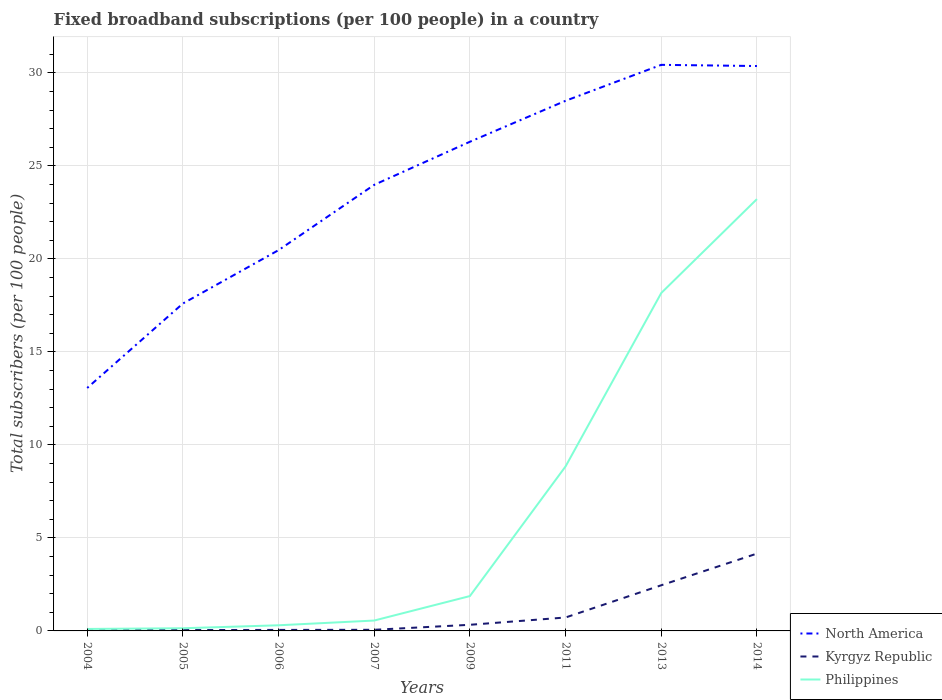How many different coloured lines are there?
Offer a terse response. 3. Is the number of lines equal to the number of legend labels?
Make the answer very short. Yes. Across all years, what is the maximum number of broadband subscriptions in Kyrgyz Republic?
Offer a terse response. 0.04. In which year was the number of broadband subscriptions in Kyrgyz Republic maximum?
Provide a succinct answer. 2004. What is the total number of broadband subscriptions in Kyrgyz Republic in the graph?
Your response must be concise. -4.1. What is the difference between the highest and the second highest number of broadband subscriptions in North America?
Your answer should be compact. 17.37. What is the difference between the highest and the lowest number of broadband subscriptions in Philippines?
Your answer should be very brief. 3. Is the number of broadband subscriptions in Philippines strictly greater than the number of broadband subscriptions in North America over the years?
Your response must be concise. Yes. How many lines are there?
Keep it short and to the point. 3. What is the difference between two consecutive major ticks on the Y-axis?
Ensure brevity in your answer.  5. Are the values on the major ticks of Y-axis written in scientific E-notation?
Your answer should be compact. No. Where does the legend appear in the graph?
Your response must be concise. Bottom right. What is the title of the graph?
Offer a very short reply. Fixed broadband subscriptions (per 100 people) in a country. Does "United Arab Emirates" appear as one of the legend labels in the graph?
Your answer should be compact. No. What is the label or title of the X-axis?
Your answer should be very brief. Years. What is the label or title of the Y-axis?
Your answer should be compact. Total subscribers (per 100 people). What is the Total subscribers (per 100 people) of North America in 2004?
Give a very brief answer. 13.06. What is the Total subscribers (per 100 people) in Kyrgyz Republic in 2004?
Provide a short and direct response. 0.04. What is the Total subscribers (per 100 people) of Philippines in 2004?
Your answer should be compact. 0.11. What is the Total subscribers (per 100 people) of North America in 2005?
Make the answer very short. 17.6. What is the Total subscribers (per 100 people) of Kyrgyz Republic in 2005?
Your response must be concise. 0.05. What is the Total subscribers (per 100 people) of Philippines in 2005?
Your answer should be compact. 0.14. What is the Total subscribers (per 100 people) of North America in 2006?
Your answer should be very brief. 20.47. What is the Total subscribers (per 100 people) of Kyrgyz Republic in 2006?
Your answer should be very brief. 0.05. What is the Total subscribers (per 100 people) of Philippines in 2006?
Offer a very short reply. 0.3. What is the Total subscribers (per 100 people) of North America in 2007?
Ensure brevity in your answer.  23.99. What is the Total subscribers (per 100 people) in Kyrgyz Republic in 2007?
Give a very brief answer. 0.06. What is the Total subscribers (per 100 people) of Philippines in 2007?
Your answer should be very brief. 0.56. What is the Total subscribers (per 100 people) in North America in 2009?
Offer a terse response. 26.3. What is the Total subscribers (per 100 people) in Kyrgyz Republic in 2009?
Provide a succinct answer. 0.33. What is the Total subscribers (per 100 people) in Philippines in 2009?
Your response must be concise. 1.87. What is the Total subscribers (per 100 people) of North America in 2011?
Provide a succinct answer. 28.51. What is the Total subscribers (per 100 people) in Kyrgyz Republic in 2011?
Ensure brevity in your answer.  0.72. What is the Total subscribers (per 100 people) of Philippines in 2011?
Give a very brief answer. 8.85. What is the Total subscribers (per 100 people) of North America in 2013?
Provide a short and direct response. 30.44. What is the Total subscribers (per 100 people) in Kyrgyz Republic in 2013?
Offer a very short reply. 2.46. What is the Total subscribers (per 100 people) in Philippines in 2013?
Provide a short and direct response. 18.17. What is the Total subscribers (per 100 people) in North America in 2014?
Your answer should be very brief. 30.37. What is the Total subscribers (per 100 people) in Kyrgyz Republic in 2014?
Your answer should be very brief. 4.16. What is the Total subscribers (per 100 people) in Philippines in 2014?
Offer a very short reply. 23.22. Across all years, what is the maximum Total subscribers (per 100 people) of North America?
Offer a very short reply. 30.44. Across all years, what is the maximum Total subscribers (per 100 people) in Kyrgyz Republic?
Provide a short and direct response. 4.16. Across all years, what is the maximum Total subscribers (per 100 people) of Philippines?
Your answer should be very brief. 23.22. Across all years, what is the minimum Total subscribers (per 100 people) in North America?
Give a very brief answer. 13.06. Across all years, what is the minimum Total subscribers (per 100 people) in Kyrgyz Republic?
Provide a succinct answer. 0.04. Across all years, what is the minimum Total subscribers (per 100 people) of Philippines?
Ensure brevity in your answer.  0.11. What is the total Total subscribers (per 100 people) in North America in the graph?
Provide a succinct answer. 190.75. What is the total Total subscribers (per 100 people) in Kyrgyz Republic in the graph?
Ensure brevity in your answer.  7.86. What is the total Total subscribers (per 100 people) in Philippines in the graph?
Your response must be concise. 53.22. What is the difference between the Total subscribers (per 100 people) of North America in 2004 and that in 2005?
Your answer should be compact. -4.54. What is the difference between the Total subscribers (per 100 people) of Kyrgyz Republic in 2004 and that in 2005?
Your answer should be very brief. -0.01. What is the difference between the Total subscribers (per 100 people) of Philippines in 2004 and that in 2005?
Ensure brevity in your answer.  -0.04. What is the difference between the Total subscribers (per 100 people) of North America in 2004 and that in 2006?
Provide a short and direct response. -7.41. What is the difference between the Total subscribers (per 100 people) of Kyrgyz Republic in 2004 and that in 2006?
Give a very brief answer. -0.02. What is the difference between the Total subscribers (per 100 people) of Philippines in 2004 and that in 2006?
Give a very brief answer. -0.2. What is the difference between the Total subscribers (per 100 people) of North America in 2004 and that in 2007?
Your response must be concise. -10.92. What is the difference between the Total subscribers (per 100 people) of Kyrgyz Republic in 2004 and that in 2007?
Provide a short and direct response. -0.02. What is the difference between the Total subscribers (per 100 people) in Philippines in 2004 and that in 2007?
Offer a very short reply. -0.45. What is the difference between the Total subscribers (per 100 people) in North America in 2004 and that in 2009?
Provide a succinct answer. -13.24. What is the difference between the Total subscribers (per 100 people) of Kyrgyz Republic in 2004 and that in 2009?
Provide a short and direct response. -0.29. What is the difference between the Total subscribers (per 100 people) of Philippines in 2004 and that in 2009?
Your answer should be very brief. -1.77. What is the difference between the Total subscribers (per 100 people) of North America in 2004 and that in 2011?
Your response must be concise. -15.44. What is the difference between the Total subscribers (per 100 people) of Kyrgyz Republic in 2004 and that in 2011?
Your response must be concise. -0.68. What is the difference between the Total subscribers (per 100 people) in Philippines in 2004 and that in 2011?
Your answer should be very brief. -8.74. What is the difference between the Total subscribers (per 100 people) of North America in 2004 and that in 2013?
Provide a short and direct response. -17.37. What is the difference between the Total subscribers (per 100 people) of Kyrgyz Republic in 2004 and that in 2013?
Your answer should be compact. -2.42. What is the difference between the Total subscribers (per 100 people) in Philippines in 2004 and that in 2013?
Ensure brevity in your answer.  -18.06. What is the difference between the Total subscribers (per 100 people) in North America in 2004 and that in 2014?
Provide a succinct answer. -17.31. What is the difference between the Total subscribers (per 100 people) in Kyrgyz Republic in 2004 and that in 2014?
Keep it short and to the point. -4.12. What is the difference between the Total subscribers (per 100 people) of Philippines in 2004 and that in 2014?
Your answer should be compact. -23.11. What is the difference between the Total subscribers (per 100 people) of North America in 2005 and that in 2006?
Offer a very short reply. -2.87. What is the difference between the Total subscribers (per 100 people) in Kyrgyz Republic in 2005 and that in 2006?
Offer a terse response. -0.01. What is the difference between the Total subscribers (per 100 people) in Philippines in 2005 and that in 2006?
Make the answer very short. -0.16. What is the difference between the Total subscribers (per 100 people) of North America in 2005 and that in 2007?
Make the answer very short. -6.38. What is the difference between the Total subscribers (per 100 people) of Kyrgyz Republic in 2005 and that in 2007?
Make the answer very short. -0.02. What is the difference between the Total subscribers (per 100 people) in Philippines in 2005 and that in 2007?
Your response must be concise. -0.41. What is the difference between the Total subscribers (per 100 people) of North America in 2005 and that in 2009?
Keep it short and to the point. -8.7. What is the difference between the Total subscribers (per 100 people) of Kyrgyz Republic in 2005 and that in 2009?
Make the answer very short. -0.28. What is the difference between the Total subscribers (per 100 people) of Philippines in 2005 and that in 2009?
Your answer should be compact. -1.73. What is the difference between the Total subscribers (per 100 people) of North America in 2005 and that in 2011?
Provide a short and direct response. -10.9. What is the difference between the Total subscribers (per 100 people) of Kyrgyz Republic in 2005 and that in 2011?
Your response must be concise. -0.68. What is the difference between the Total subscribers (per 100 people) in Philippines in 2005 and that in 2011?
Keep it short and to the point. -8.7. What is the difference between the Total subscribers (per 100 people) in North America in 2005 and that in 2013?
Offer a very short reply. -12.83. What is the difference between the Total subscribers (per 100 people) in Kyrgyz Republic in 2005 and that in 2013?
Offer a terse response. -2.41. What is the difference between the Total subscribers (per 100 people) in Philippines in 2005 and that in 2013?
Keep it short and to the point. -18.03. What is the difference between the Total subscribers (per 100 people) in North America in 2005 and that in 2014?
Ensure brevity in your answer.  -12.77. What is the difference between the Total subscribers (per 100 people) in Kyrgyz Republic in 2005 and that in 2014?
Your answer should be very brief. -4.11. What is the difference between the Total subscribers (per 100 people) in Philippines in 2005 and that in 2014?
Your response must be concise. -23.08. What is the difference between the Total subscribers (per 100 people) in North America in 2006 and that in 2007?
Provide a succinct answer. -3.51. What is the difference between the Total subscribers (per 100 people) of Kyrgyz Republic in 2006 and that in 2007?
Offer a very short reply. -0.01. What is the difference between the Total subscribers (per 100 people) of Philippines in 2006 and that in 2007?
Ensure brevity in your answer.  -0.25. What is the difference between the Total subscribers (per 100 people) in North America in 2006 and that in 2009?
Offer a terse response. -5.83. What is the difference between the Total subscribers (per 100 people) of Kyrgyz Republic in 2006 and that in 2009?
Your response must be concise. -0.28. What is the difference between the Total subscribers (per 100 people) in Philippines in 2006 and that in 2009?
Provide a short and direct response. -1.57. What is the difference between the Total subscribers (per 100 people) in North America in 2006 and that in 2011?
Provide a short and direct response. -8.03. What is the difference between the Total subscribers (per 100 people) in Kyrgyz Republic in 2006 and that in 2011?
Ensure brevity in your answer.  -0.67. What is the difference between the Total subscribers (per 100 people) of Philippines in 2006 and that in 2011?
Offer a very short reply. -8.54. What is the difference between the Total subscribers (per 100 people) of North America in 2006 and that in 2013?
Offer a terse response. -9.96. What is the difference between the Total subscribers (per 100 people) in Kyrgyz Republic in 2006 and that in 2013?
Offer a very short reply. -2.4. What is the difference between the Total subscribers (per 100 people) in Philippines in 2006 and that in 2013?
Your response must be concise. -17.87. What is the difference between the Total subscribers (per 100 people) of North America in 2006 and that in 2014?
Your answer should be compact. -9.9. What is the difference between the Total subscribers (per 100 people) in Kyrgyz Republic in 2006 and that in 2014?
Your answer should be very brief. -4.1. What is the difference between the Total subscribers (per 100 people) in Philippines in 2006 and that in 2014?
Make the answer very short. -22.92. What is the difference between the Total subscribers (per 100 people) of North America in 2007 and that in 2009?
Offer a very short reply. -2.32. What is the difference between the Total subscribers (per 100 people) in Kyrgyz Republic in 2007 and that in 2009?
Make the answer very short. -0.27. What is the difference between the Total subscribers (per 100 people) of Philippines in 2007 and that in 2009?
Make the answer very short. -1.32. What is the difference between the Total subscribers (per 100 people) in North America in 2007 and that in 2011?
Give a very brief answer. -4.52. What is the difference between the Total subscribers (per 100 people) of Kyrgyz Republic in 2007 and that in 2011?
Your answer should be compact. -0.66. What is the difference between the Total subscribers (per 100 people) of Philippines in 2007 and that in 2011?
Give a very brief answer. -8.29. What is the difference between the Total subscribers (per 100 people) in North America in 2007 and that in 2013?
Provide a short and direct response. -6.45. What is the difference between the Total subscribers (per 100 people) of Kyrgyz Republic in 2007 and that in 2013?
Your answer should be very brief. -2.39. What is the difference between the Total subscribers (per 100 people) in Philippines in 2007 and that in 2013?
Provide a short and direct response. -17.61. What is the difference between the Total subscribers (per 100 people) of North America in 2007 and that in 2014?
Give a very brief answer. -6.39. What is the difference between the Total subscribers (per 100 people) in Kyrgyz Republic in 2007 and that in 2014?
Make the answer very short. -4.1. What is the difference between the Total subscribers (per 100 people) in Philippines in 2007 and that in 2014?
Provide a short and direct response. -22.66. What is the difference between the Total subscribers (per 100 people) in North America in 2009 and that in 2011?
Offer a terse response. -2.2. What is the difference between the Total subscribers (per 100 people) of Kyrgyz Republic in 2009 and that in 2011?
Offer a very short reply. -0.39. What is the difference between the Total subscribers (per 100 people) of Philippines in 2009 and that in 2011?
Keep it short and to the point. -6.97. What is the difference between the Total subscribers (per 100 people) in North America in 2009 and that in 2013?
Provide a short and direct response. -4.14. What is the difference between the Total subscribers (per 100 people) in Kyrgyz Republic in 2009 and that in 2013?
Your answer should be compact. -2.13. What is the difference between the Total subscribers (per 100 people) of Philippines in 2009 and that in 2013?
Provide a short and direct response. -16.3. What is the difference between the Total subscribers (per 100 people) of North America in 2009 and that in 2014?
Your answer should be very brief. -4.07. What is the difference between the Total subscribers (per 100 people) in Kyrgyz Republic in 2009 and that in 2014?
Provide a succinct answer. -3.83. What is the difference between the Total subscribers (per 100 people) of Philippines in 2009 and that in 2014?
Offer a very short reply. -21.34. What is the difference between the Total subscribers (per 100 people) of North America in 2011 and that in 2013?
Give a very brief answer. -1.93. What is the difference between the Total subscribers (per 100 people) in Kyrgyz Republic in 2011 and that in 2013?
Make the answer very short. -1.73. What is the difference between the Total subscribers (per 100 people) of Philippines in 2011 and that in 2013?
Provide a succinct answer. -9.32. What is the difference between the Total subscribers (per 100 people) in North America in 2011 and that in 2014?
Ensure brevity in your answer.  -1.87. What is the difference between the Total subscribers (per 100 people) of Kyrgyz Republic in 2011 and that in 2014?
Your answer should be very brief. -3.44. What is the difference between the Total subscribers (per 100 people) in Philippines in 2011 and that in 2014?
Offer a terse response. -14.37. What is the difference between the Total subscribers (per 100 people) in North America in 2013 and that in 2014?
Provide a short and direct response. 0.06. What is the difference between the Total subscribers (per 100 people) of Kyrgyz Republic in 2013 and that in 2014?
Provide a succinct answer. -1.7. What is the difference between the Total subscribers (per 100 people) of Philippines in 2013 and that in 2014?
Keep it short and to the point. -5.05. What is the difference between the Total subscribers (per 100 people) in North America in 2004 and the Total subscribers (per 100 people) in Kyrgyz Republic in 2005?
Your answer should be compact. 13.02. What is the difference between the Total subscribers (per 100 people) of North America in 2004 and the Total subscribers (per 100 people) of Philippines in 2005?
Offer a very short reply. 12.92. What is the difference between the Total subscribers (per 100 people) in Kyrgyz Republic in 2004 and the Total subscribers (per 100 people) in Philippines in 2005?
Keep it short and to the point. -0.11. What is the difference between the Total subscribers (per 100 people) of North America in 2004 and the Total subscribers (per 100 people) of Kyrgyz Republic in 2006?
Offer a terse response. 13.01. What is the difference between the Total subscribers (per 100 people) in North America in 2004 and the Total subscribers (per 100 people) in Philippines in 2006?
Your answer should be very brief. 12.76. What is the difference between the Total subscribers (per 100 people) of Kyrgyz Republic in 2004 and the Total subscribers (per 100 people) of Philippines in 2006?
Your answer should be compact. -0.27. What is the difference between the Total subscribers (per 100 people) in North America in 2004 and the Total subscribers (per 100 people) in Kyrgyz Republic in 2007?
Provide a succinct answer. 13. What is the difference between the Total subscribers (per 100 people) of North America in 2004 and the Total subscribers (per 100 people) of Philippines in 2007?
Offer a terse response. 12.5. What is the difference between the Total subscribers (per 100 people) in Kyrgyz Republic in 2004 and the Total subscribers (per 100 people) in Philippines in 2007?
Ensure brevity in your answer.  -0.52. What is the difference between the Total subscribers (per 100 people) of North America in 2004 and the Total subscribers (per 100 people) of Kyrgyz Republic in 2009?
Offer a very short reply. 12.73. What is the difference between the Total subscribers (per 100 people) of North America in 2004 and the Total subscribers (per 100 people) of Philippines in 2009?
Provide a succinct answer. 11.19. What is the difference between the Total subscribers (per 100 people) in Kyrgyz Republic in 2004 and the Total subscribers (per 100 people) in Philippines in 2009?
Give a very brief answer. -1.84. What is the difference between the Total subscribers (per 100 people) in North America in 2004 and the Total subscribers (per 100 people) in Kyrgyz Republic in 2011?
Your answer should be very brief. 12.34. What is the difference between the Total subscribers (per 100 people) in North America in 2004 and the Total subscribers (per 100 people) in Philippines in 2011?
Make the answer very short. 4.22. What is the difference between the Total subscribers (per 100 people) of Kyrgyz Republic in 2004 and the Total subscribers (per 100 people) of Philippines in 2011?
Offer a terse response. -8.81. What is the difference between the Total subscribers (per 100 people) of North America in 2004 and the Total subscribers (per 100 people) of Kyrgyz Republic in 2013?
Ensure brevity in your answer.  10.61. What is the difference between the Total subscribers (per 100 people) in North America in 2004 and the Total subscribers (per 100 people) in Philippines in 2013?
Your answer should be very brief. -5.11. What is the difference between the Total subscribers (per 100 people) of Kyrgyz Republic in 2004 and the Total subscribers (per 100 people) of Philippines in 2013?
Offer a terse response. -18.13. What is the difference between the Total subscribers (per 100 people) of North America in 2004 and the Total subscribers (per 100 people) of Kyrgyz Republic in 2014?
Your answer should be very brief. 8.9. What is the difference between the Total subscribers (per 100 people) of North America in 2004 and the Total subscribers (per 100 people) of Philippines in 2014?
Provide a succinct answer. -10.16. What is the difference between the Total subscribers (per 100 people) of Kyrgyz Republic in 2004 and the Total subscribers (per 100 people) of Philippines in 2014?
Your answer should be compact. -23.18. What is the difference between the Total subscribers (per 100 people) of North America in 2005 and the Total subscribers (per 100 people) of Kyrgyz Republic in 2006?
Offer a very short reply. 17.55. What is the difference between the Total subscribers (per 100 people) in North America in 2005 and the Total subscribers (per 100 people) in Philippines in 2006?
Your answer should be very brief. 17.3. What is the difference between the Total subscribers (per 100 people) of Kyrgyz Republic in 2005 and the Total subscribers (per 100 people) of Philippines in 2006?
Offer a terse response. -0.26. What is the difference between the Total subscribers (per 100 people) in North America in 2005 and the Total subscribers (per 100 people) in Kyrgyz Republic in 2007?
Provide a succinct answer. 17.54. What is the difference between the Total subscribers (per 100 people) of North America in 2005 and the Total subscribers (per 100 people) of Philippines in 2007?
Ensure brevity in your answer.  17.05. What is the difference between the Total subscribers (per 100 people) in Kyrgyz Republic in 2005 and the Total subscribers (per 100 people) in Philippines in 2007?
Your response must be concise. -0.51. What is the difference between the Total subscribers (per 100 people) in North America in 2005 and the Total subscribers (per 100 people) in Kyrgyz Republic in 2009?
Keep it short and to the point. 17.27. What is the difference between the Total subscribers (per 100 people) in North America in 2005 and the Total subscribers (per 100 people) in Philippines in 2009?
Offer a terse response. 15.73. What is the difference between the Total subscribers (per 100 people) in Kyrgyz Republic in 2005 and the Total subscribers (per 100 people) in Philippines in 2009?
Keep it short and to the point. -1.83. What is the difference between the Total subscribers (per 100 people) in North America in 2005 and the Total subscribers (per 100 people) in Kyrgyz Republic in 2011?
Your answer should be very brief. 16.88. What is the difference between the Total subscribers (per 100 people) in North America in 2005 and the Total subscribers (per 100 people) in Philippines in 2011?
Keep it short and to the point. 8.76. What is the difference between the Total subscribers (per 100 people) of Kyrgyz Republic in 2005 and the Total subscribers (per 100 people) of Philippines in 2011?
Provide a short and direct response. -8.8. What is the difference between the Total subscribers (per 100 people) of North America in 2005 and the Total subscribers (per 100 people) of Kyrgyz Republic in 2013?
Provide a short and direct response. 15.15. What is the difference between the Total subscribers (per 100 people) in North America in 2005 and the Total subscribers (per 100 people) in Philippines in 2013?
Ensure brevity in your answer.  -0.57. What is the difference between the Total subscribers (per 100 people) of Kyrgyz Republic in 2005 and the Total subscribers (per 100 people) of Philippines in 2013?
Offer a very short reply. -18.12. What is the difference between the Total subscribers (per 100 people) in North America in 2005 and the Total subscribers (per 100 people) in Kyrgyz Republic in 2014?
Your response must be concise. 13.45. What is the difference between the Total subscribers (per 100 people) in North America in 2005 and the Total subscribers (per 100 people) in Philippines in 2014?
Make the answer very short. -5.62. What is the difference between the Total subscribers (per 100 people) in Kyrgyz Republic in 2005 and the Total subscribers (per 100 people) in Philippines in 2014?
Give a very brief answer. -23.17. What is the difference between the Total subscribers (per 100 people) in North America in 2006 and the Total subscribers (per 100 people) in Kyrgyz Republic in 2007?
Offer a very short reply. 20.41. What is the difference between the Total subscribers (per 100 people) of North America in 2006 and the Total subscribers (per 100 people) of Philippines in 2007?
Your response must be concise. 19.92. What is the difference between the Total subscribers (per 100 people) in Kyrgyz Republic in 2006 and the Total subscribers (per 100 people) in Philippines in 2007?
Ensure brevity in your answer.  -0.5. What is the difference between the Total subscribers (per 100 people) in North America in 2006 and the Total subscribers (per 100 people) in Kyrgyz Republic in 2009?
Your answer should be very brief. 20.14. What is the difference between the Total subscribers (per 100 people) of North America in 2006 and the Total subscribers (per 100 people) of Philippines in 2009?
Your answer should be very brief. 18.6. What is the difference between the Total subscribers (per 100 people) of Kyrgyz Republic in 2006 and the Total subscribers (per 100 people) of Philippines in 2009?
Give a very brief answer. -1.82. What is the difference between the Total subscribers (per 100 people) of North America in 2006 and the Total subscribers (per 100 people) of Kyrgyz Republic in 2011?
Your answer should be compact. 19.75. What is the difference between the Total subscribers (per 100 people) in North America in 2006 and the Total subscribers (per 100 people) in Philippines in 2011?
Your response must be concise. 11.63. What is the difference between the Total subscribers (per 100 people) of Kyrgyz Republic in 2006 and the Total subscribers (per 100 people) of Philippines in 2011?
Your answer should be compact. -8.79. What is the difference between the Total subscribers (per 100 people) in North America in 2006 and the Total subscribers (per 100 people) in Kyrgyz Republic in 2013?
Provide a short and direct response. 18.02. What is the difference between the Total subscribers (per 100 people) in North America in 2006 and the Total subscribers (per 100 people) in Philippines in 2013?
Make the answer very short. 2.3. What is the difference between the Total subscribers (per 100 people) in Kyrgyz Republic in 2006 and the Total subscribers (per 100 people) in Philippines in 2013?
Provide a succinct answer. -18.12. What is the difference between the Total subscribers (per 100 people) in North America in 2006 and the Total subscribers (per 100 people) in Kyrgyz Republic in 2014?
Give a very brief answer. 16.32. What is the difference between the Total subscribers (per 100 people) of North America in 2006 and the Total subscribers (per 100 people) of Philippines in 2014?
Provide a short and direct response. -2.75. What is the difference between the Total subscribers (per 100 people) in Kyrgyz Republic in 2006 and the Total subscribers (per 100 people) in Philippines in 2014?
Ensure brevity in your answer.  -23.16. What is the difference between the Total subscribers (per 100 people) in North America in 2007 and the Total subscribers (per 100 people) in Kyrgyz Republic in 2009?
Provide a short and direct response. 23.66. What is the difference between the Total subscribers (per 100 people) of North America in 2007 and the Total subscribers (per 100 people) of Philippines in 2009?
Make the answer very short. 22.11. What is the difference between the Total subscribers (per 100 people) in Kyrgyz Republic in 2007 and the Total subscribers (per 100 people) in Philippines in 2009?
Give a very brief answer. -1.81. What is the difference between the Total subscribers (per 100 people) in North America in 2007 and the Total subscribers (per 100 people) in Kyrgyz Republic in 2011?
Provide a short and direct response. 23.26. What is the difference between the Total subscribers (per 100 people) in North America in 2007 and the Total subscribers (per 100 people) in Philippines in 2011?
Make the answer very short. 15.14. What is the difference between the Total subscribers (per 100 people) in Kyrgyz Republic in 2007 and the Total subscribers (per 100 people) in Philippines in 2011?
Provide a succinct answer. -8.79. What is the difference between the Total subscribers (per 100 people) of North America in 2007 and the Total subscribers (per 100 people) of Kyrgyz Republic in 2013?
Your response must be concise. 21.53. What is the difference between the Total subscribers (per 100 people) in North America in 2007 and the Total subscribers (per 100 people) in Philippines in 2013?
Ensure brevity in your answer.  5.82. What is the difference between the Total subscribers (per 100 people) of Kyrgyz Republic in 2007 and the Total subscribers (per 100 people) of Philippines in 2013?
Offer a terse response. -18.11. What is the difference between the Total subscribers (per 100 people) of North America in 2007 and the Total subscribers (per 100 people) of Kyrgyz Republic in 2014?
Your response must be concise. 19.83. What is the difference between the Total subscribers (per 100 people) in North America in 2007 and the Total subscribers (per 100 people) in Philippines in 2014?
Ensure brevity in your answer.  0.77. What is the difference between the Total subscribers (per 100 people) of Kyrgyz Republic in 2007 and the Total subscribers (per 100 people) of Philippines in 2014?
Keep it short and to the point. -23.16. What is the difference between the Total subscribers (per 100 people) in North America in 2009 and the Total subscribers (per 100 people) in Kyrgyz Republic in 2011?
Your response must be concise. 25.58. What is the difference between the Total subscribers (per 100 people) of North America in 2009 and the Total subscribers (per 100 people) of Philippines in 2011?
Provide a succinct answer. 17.46. What is the difference between the Total subscribers (per 100 people) of Kyrgyz Republic in 2009 and the Total subscribers (per 100 people) of Philippines in 2011?
Your answer should be compact. -8.52. What is the difference between the Total subscribers (per 100 people) in North America in 2009 and the Total subscribers (per 100 people) in Kyrgyz Republic in 2013?
Provide a short and direct response. 23.85. What is the difference between the Total subscribers (per 100 people) in North America in 2009 and the Total subscribers (per 100 people) in Philippines in 2013?
Give a very brief answer. 8.13. What is the difference between the Total subscribers (per 100 people) of Kyrgyz Republic in 2009 and the Total subscribers (per 100 people) of Philippines in 2013?
Your response must be concise. -17.84. What is the difference between the Total subscribers (per 100 people) in North America in 2009 and the Total subscribers (per 100 people) in Kyrgyz Republic in 2014?
Offer a very short reply. 22.14. What is the difference between the Total subscribers (per 100 people) in North America in 2009 and the Total subscribers (per 100 people) in Philippines in 2014?
Give a very brief answer. 3.08. What is the difference between the Total subscribers (per 100 people) in Kyrgyz Republic in 2009 and the Total subscribers (per 100 people) in Philippines in 2014?
Provide a succinct answer. -22.89. What is the difference between the Total subscribers (per 100 people) in North America in 2011 and the Total subscribers (per 100 people) in Kyrgyz Republic in 2013?
Offer a very short reply. 26.05. What is the difference between the Total subscribers (per 100 people) in North America in 2011 and the Total subscribers (per 100 people) in Philippines in 2013?
Your answer should be very brief. 10.34. What is the difference between the Total subscribers (per 100 people) in Kyrgyz Republic in 2011 and the Total subscribers (per 100 people) in Philippines in 2013?
Give a very brief answer. -17.45. What is the difference between the Total subscribers (per 100 people) in North America in 2011 and the Total subscribers (per 100 people) in Kyrgyz Republic in 2014?
Your answer should be very brief. 24.35. What is the difference between the Total subscribers (per 100 people) of North America in 2011 and the Total subscribers (per 100 people) of Philippines in 2014?
Provide a short and direct response. 5.29. What is the difference between the Total subscribers (per 100 people) in Kyrgyz Republic in 2011 and the Total subscribers (per 100 people) in Philippines in 2014?
Your response must be concise. -22.5. What is the difference between the Total subscribers (per 100 people) of North America in 2013 and the Total subscribers (per 100 people) of Kyrgyz Republic in 2014?
Keep it short and to the point. 26.28. What is the difference between the Total subscribers (per 100 people) in North America in 2013 and the Total subscribers (per 100 people) in Philippines in 2014?
Offer a very short reply. 7.22. What is the difference between the Total subscribers (per 100 people) in Kyrgyz Republic in 2013 and the Total subscribers (per 100 people) in Philippines in 2014?
Your response must be concise. -20.76. What is the average Total subscribers (per 100 people) in North America per year?
Your answer should be compact. 23.84. What is the average Total subscribers (per 100 people) of Kyrgyz Republic per year?
Offer a terse response. 0.98. What is the average Total subscribers (per 100 people) of Philippines per year?
Offer a terse response. 6.65. In the year 2004, what is the difference between the Total subscribers (per 100 people) in North America and Total subscribers (per 100 people) in Kyrgyz Republic?
Offer a terse response. 13.03. In the year 2004, what is the difference between the Total subscribers (per 100 people) of North America and Total subscribers (per 100 people) of Philippines?
Keep it short and to the point. 12.96. In the year 2004, what is the difference between the Total subscribers (per 100 people) of Kyrgyz Republic and Total subscribers (per 100 people) of Philippines?
Ensure brevity in your answer.  -0.07. In the year 2005, what is the difference between the Total subscribers (per 100 people) of North America and Total subscribers (per 100 people) of Kyrgyz Republic?
Offer a very short reply. 17.56. In the year 2005, what is the difference between the Total subscribers (per 100 people) of North America and Total subscribers (per 100 people) of Philippines?
Provide a succinct answer. 17.46. In the year 2005, what is the difference between the Total subscribers (per 100 people) of Kyrgyz Republic and Total subscribers (per 100 people) of Philippines?
Provide a short and direct response. -0.1. In the year 2006, what is the difference between the Total subscribers (per 100 people) in North America and Total subscribers (per 100 people) in Kyrgyz Republic?
Your response must be concise. 20.42. In the year 2006, what is the difference between the Total subscribers (per 100 people) in North America and Total subscribers (per 100 people) in Philippines?
Offer a terse response. 20.17. In the year 2006, what is the difference between the Total subscribers (per 100 people) of Kyrgyz Republic and Total subscribers (per 100 people) of Philippines?
Keep it short and to the point. -0.25. In the year 2007, what is the difference between the Total subscribers (per 100 people) of North America and Total subscribers (per 100 people) of Kyrgyz Republic?
Make the answer very short. 23.93. In the year 2007, what is the difference between the Total subscribers (per 100 people) in North America and Total subscribers (per 100 people) in Philippines?
Your answer should be very brief. 23.43. In the year 2007, what is the difference between the Total subscribers (per 100 people) of Kyrgyz Republic and Total subscribers (per 100 people) of Philippines?
Keep it short and to the point. -0.5. In the year 2009, what is the difference between the Total subscribers (per 100 people) in North America and Total subscribers (per 100 people) in Kyrgyz Republic?
Offer a very short reply. 25.97. In the year 2009, what is the difference between the Total subscribers (per 100 people) in North America and Total subscribers (per 100 people) in Philippines?
Ensure brevity in your answer.  24.43. In the year 2009, what is the difference between the Total subscribers (per 100 people) in Kyrgyz Republic and Total subscribers (per 100 people) in Philippines?
Provide a short and direct response. -1.54. In the year 2011, what is the difference between the Total subscribers (per 100 people) of North America and Total subscribers (per 100 people) of Kyrgyz Republic?
Your answer should be very brief. 27.78. In the year 2011, what is the difference between the Total subscribers (per 100 people) in North America and Total subscribers (per 100 people) in Philippines?
Your answer should be compact. 19.66. In the year 2011, what is the difference between the Total subscribers (per 100 people) in Kyrgyz Republic and Total subscribers (per 100 people) in Philippines?
Make the answer very short. -8.12. In the year 2013, what is the difference between the Total subscribers (per 100 people) of North America and Total subscribers (per 100 people) of Kyrgyz Republic?
Ensure brevity in your answer.  27.98. In the year 2013, what is the difference between the Total subscribers (per 100 people) in North America and Total subscribers (per 100 people) in Philippines?
Provide a succinct answer. 12.27. In the year 2013, what is the difference between the Total subscribers (per 100 people) in Kyrgyz Republic and Total subscribers (per 100 people) in Philippines?
Your answer should be very brief. -15.71. In the year 2014, what is the difference between the Total subscribers (per 100 people) of North America and Total subscribers (per 100 people) of Kyrgyz Republic?
Make the answer very short. 26.22. In the year 2014, what is the difference between the Total subscribers (per 100 people) of North America and Total subscribers (per 100 people) of Philippines?
Provide a succinct answer. 7.15. In the year 2014, what is the difference between the Total subscribers (per 100 people) in Kyrgyz Republic and Total subscribers (per 100 people) in Philippines?
Ensure brevity in your answer.  -19.06. What is the ratio of the Total subscribers (per 100 people) of North America in 2004 to that in 2005?
Ensure brevity in your answer.  0.74. What is the ratio of the Total subscribers (per 100 people) in Kyrgyz Republic in 2004 to that in 2005?
Your answer should be compact. 0.84. What is the ratio of the Total subscribers (per 100 people) in Philippines in 2004 to that in 2005?
Make the answer very short. 0.74. What is the ratio of the Total subscribers (per 100 people) in North America in 2004 to that in 2006?
Your answer should be compact. 0.64. What is the ratio of the Total subscribers (per 100 people) in Kyrgyz Republic in 2004 to that in 2006?
Give a very brief answer. 0.7. What is the ratio of the Total subscribers (per 100 people) in Philippines in 2004 to that in 2006?
Ensure brevity in your answer.  0.35. What is the ratio of the Total subscribers (per 100 people) of North America in 2004 to that in 2007?
Your answer should be very brief. 0.54. What is the ratio of the Total subscribers (per 100 people) of Kyrgyz Republic in 2004 to that in 2007?
Offer a very short reply. 0.63. What is the ratio of the Total subscribers (per 100 people) in Philippines in 2004 to that in 2007?
Make the answer very short. 0.19. What is the ratio of the Total subscribers (per 100 people) of North America in 2004 to that in 2009?
Your answer should be compact. 0.5. What is the ratio of the Total subscribers (per 100 people) in Kyrgyz Republic in 2004 to that in 2009?
Offer a terse response. 0.12. What is the ratio of the Total subscribers (per 100 people) of Philippines in 2004 to that in 2009?
Keep it short and to the point. 0.06. What is the ratio of the Total subscribers (per 100 people) of North America in 2004 to that in 2011?
Your answer should be very brief. 0.46. What is the ratio of the Total subscribers (per 100 people) in Kyrgyz Republic in 2004 to that in 2011?
Offer a very short reply. 0.05. What is the ratio of the Total subscribers (per 100 people) in Philippines in 2004 to that in 2011?
Your answer should be compact. 0.01. What is the ratio of the Total subscribers (per 100 people) of North America in 2004 to that in 2013?
Your answer should be very brief. 0.43. What is the ratio of the Total subscribers (per 100 people) of Kyrgyz Republic in 2004 to that in 2013?
Make the answer very short. 0.02. What is the ratio of the Total subscribers (per 100 people) in Philippines in 2004 to that in 2013?
Provide a short and direct response. 0.01. What is the ratio of the Total subscribers (per 100 people) in North America in 2004 to that in 2014?
Your response must be concise. 0.43. What is the ratio of the Total subscribers (per 100 people) in Kyrgyz Republic in 2004 to that in 2014?
Offer a terse response. 0.01. What is the ratio of the Total subscribers (per 100 people) in Philippines in 2004 to that in 2014?
Your answer should be very brief. 0. What is the ratio of the Total subscribers (per 100 people) of North America in 2005 to that in 2006?
Provide a short and direct response. 0.86. What is the ratio of the Total subscribers (per 100 people) of Kyrgyz Republic in 2005 to that in 2006?
Offer a terse response. 0.84. What is the ratio of the Total subscribers (per 100 people) in Philippines in 2005 to that in 2006?
Ensure brevity in your answer.  0.47. What is the ratio of the Total subscribers (per 100 people) of North America in 2005 to that in 2007?
Make the answer very short. 0.73. What is the ratio of the Total subscribers (per 100 people) of Kyrgyz Republic in 2005 to that in 2007?
Keep it short and to the point. 0.75. What is the ratio of the Total subscribers (per 100 people) of Philippines in 2005 to that in 2007?
Provide a short and direct response. 0.26. What is the ratio of the Total subscribers (per 100 people) of North America in 2005 to that in 2009?
Give a very brief answer. 0.67. What is the ratio of the Total subscribers (per 100 people) in Kyrgyz Republic in 2005 to that in 2009?
Your answer should be compact. 0.14. What is the ratio of the Total subscribers (per 100 people) in Philippines in 2005 to that in 2009?
Offer a very short reply. 0.08. What is the ratio of the Total subscribers (per 100 people) in North America in 2005 to that in 2011?
Your answer should be compact. 0.62. What is the ratio of the Total subscribers (per 100 people) of Kyrgyz Republic in 2005 to that in 2011?
Your answer should be very brief. 0.06. What is the ratio of the Total subscribers (per 100 people) of Philippines in 2005 to that in 2011?
Provide a short and direct response. 0.02. What is the ratio of the Total subscribers (per 100 people) of North America in 2005 to that in 2013?
Keep it short and to the point. 0.58. What is the ratio of the Total subscribers (per 100 people) in Kyrgyz Republic in 2005 to that in 2013?
Make the answer very short. 0.02. What is the ratio of the Total subscribers (per 100 people) in Philippines in 2005 to that in 2013?
Your response must be concise. 0.01. What is the ratio of the Total subscribers (per 100 people) in North America in 2005 to that in 2014?
Your answer should be compact. 0.58. What is the ratio of the Total subscribers (per 100 people) of Kyrgyz Republic in 2005 to that in 2014?
Provide a short and direct response. 0.01. What is the ratio of the Total subscribers (per 100 people) of Philippines in 2005 to that in 2014?
Give a very brief answer. 0.01. What is the ratio of the Total subscribers (per 100 people) of North America in 2006 to that in 2007?
Your answer should be compact. 0.85. What is the ratio of the Total subscribers (per 100 people) in Kyrgyz Republic in 2006 to that in 2007?
Your answer should be very brief. 0.9. What is the ratio of the Total subscribers (per 100 people) in Philippines in 2006 to that in 2007?
Give a very brief answer. 0.54. What is the ratio of the Total subscribers (per 100 people) of North America in 2006 to that in 2009?
Make the answer very short. 0.78. What is the ratio of the Total subscribers (per 100 people) of Kyrgyz Republic in 2006 to that in 2009?
Offer a terse response. 0.16. What is the ratio of the Total subscribers (per 100 people) in Philippines in 2006 to that in 2009?
Offer a terse response. 0.16. What is the ratio of the Total subscribers (per 100 people) in North America in 2006 to that in 2011?
Provide a succinct answer. 0.72. What is the ratio of the Total subscribers (per 100 people) in Kyrgyz Republic in 2006 to that in 2011?
Provide a succinct answer. 0.08. What is the ratio of the Total subscribers (per 100 people) of Philippines in 2006 to that in 2011?
Provide a succinct answer. 0.03. What is the ratio of the Total subscribers (per 100 people) of North America in 2006 to that in 2013?
Ensure brevity in your answer.  0.67. What is the ratio of the Total subscribers (per 100 people) in Kyrgyz Republic in 2006 to that in 2013?
Your answer should be very brief. 0.02. What is the ratio of the Total subscribers (per 100 people) of Philippines in 2006 to that in 2013?
Keep it short and to the point. 0.02. What is the ratio of the Total subscribers (per 100 people) in North America in 2006 to that in 2014?
Keep it short and to the point. 0.67. What is the ratio of the Total subscribers (per 100 people) of Kyrgyz Republic in 2006 to that in 2014?
Offer a terse response. 0.01. What is the ratio of the Total subscribers (per 100 people) in Philippines in 2006 to that in 2014?
Your answer should be very brief. 0.01. What is the ratio of the Total subscribers (per 100 people) of North America in 2007 to that in 2009?
Provide a succinct answer. 0.91. What is the ratio of the Total subscribers (per 100 people) in Kyrgyz Republic in 2007 to that in 2009?
Provide a succinct answer. 0.18. What is the ratio of the Total subscribers (per 100 people) of Philippines in 2007 to that in 2009?
Your answer should be compact. 0.3. What is the ratio of the Total subscribers (per 100 people) in North America in 2007 to that in 2011?
Your answer should be very brief. 0.84. What is the ratio of the Total subscribers (per 100 people) of Kyrgyz Republic in 2007 to that in 2011?
Offer a very short reply. 0.08. What is the ratio of the Total subscribers (per 100 people) in Philippines in 2007 to that in 2011?
Make the answer very short. 0.06. What is the ratio of the Total subscribers (per 100 people) of North America in 2007 to that in 2013?
Your answer should be compact. 0.79. What is the ratio of the Total subscribers (per 100 people) of Kyrgyz Republic in 2007 to that in 2013?
Your answer should be compact. 0.02. What is the ratio of the Total subscribers (per 100 people) in Philippines in 2007 to that in 2013?
Ensure brevity in your answer.  0.03. What is the ratio of the Total subscribers (per 100 people) of North America in 2007 to that in 2014?
Make the answer very short. 0.79. What is the ratio of the Total subscribers (per 100 people) of Kyrgyz Republic in 2007 to that in 2014?
Give a very brief answer. 0.01. What is the ratio of the Total subscribers (per 100 people) of Philippines in 2007 to that in 2014?
Your answer should be very brief. 0.02. What is the ratio of the Total subscribers (per 100 people) of North America in 2009 to that in 2011?
Offer a very short reply. 0.92. What is the ratio of the Total subscribers (per 100 people) of Kyrgyz Republic in 2009 to that in 2011?
Your response must be concise. 0.46. What is the ratio of the Total subscribers (per 100 people) of Philippines in 2009 to that in 2011?
Offer a terse response. 0.21. What is the ratio of the Total subscribers (per 100 people) of North America in 2009 to that in 2013?
Make the answer very short. 0.86. What is the ratio of the Total subscribers (per 100 people) in Kyrgyz Republic in 2009 to that in 2013?
Offer a very short reply. 0.13. What is the ratio of the Total subscribers (per 100 people) of Philippines in 2009 to that in 2013?
Your answer should be very brief. 0.1. What is the ratio of the Total subscribers (per 100 people) of North America in 2009 to that in 2014?
Offer a terse response. 0.87. What is the ratio of the Total subscribers (per 100 people) of Kyrgyz Republic in 2009 to that in 2014?
Offer a very short reply. 0.08. What is the ratio of the Total subscribers (per 100 people) in Philippines in 2009 to that in 2014?
Give a very brief answer. 0.08. What is the ratio of the Total subscribers (per 100 people) in North America in 2011 to that in 2013?
Give a very brief answer. 0.94. What is the ratio of the Total subscribers (per 100 people) in Kyrgyz Republic in 2011 to that in 2013?
Your response must be concise. 0.29. What is the ratio of the Total subscribers (per 100 people) of Philippines in 2011 to that in 2013?
Your response must be concise. 0.49. What is the ratio of the Total subscribers (per 100 people) in North America in 2011 to that in 2014?
Ensure brevity in your answer.  0.94. What is the ratio of the Total subscribers (per 100 people) in Kyrgyz Republic in 2011 to that in 2014?
Your response must be concise. 0.17. What is the ratio of the Total subscribers (per 100 people) in Philippines in 2011 to that in 2014?
Your answer should be compact. 0.38. What is the ratio of the Total subscribers (per 100 people) in Kyrgyz Republic in 2013 to that in 2014?
Give a very brief answer. 0.59. What is the ratio of the Total subscribers (per 100 people) of Philippines in 2013 to that in 2014?
Your response must be concise. 0.78. What is the difference between the highest and the second highest Total subscribers (per 100 people) of North America?
Keep it short and to the point. 0.06. What is the difference between the highest and the second highest Total subscribers (per 100 people) in Kyrgyz Republic?
Offer a very short reply. 1.7. What is the difference between the highest and the second highest Total subscribers (per 100 people) in Philippines?
Keep it short and to the point. 5.05. What is the difference between the highest and the lowest Total subscribers (per 100 people) of North America?
Your answer should be compact. 17.37. What is the difference between the highest and the lowest Total subscribers (per 100 people) of Kyrgyz Republic?
Give a very brief answer. 4.12. What is the difference between the highest and the lowest Total subscribers (per 100 people) of Philippines?
Your response must be concise. 23.11. 